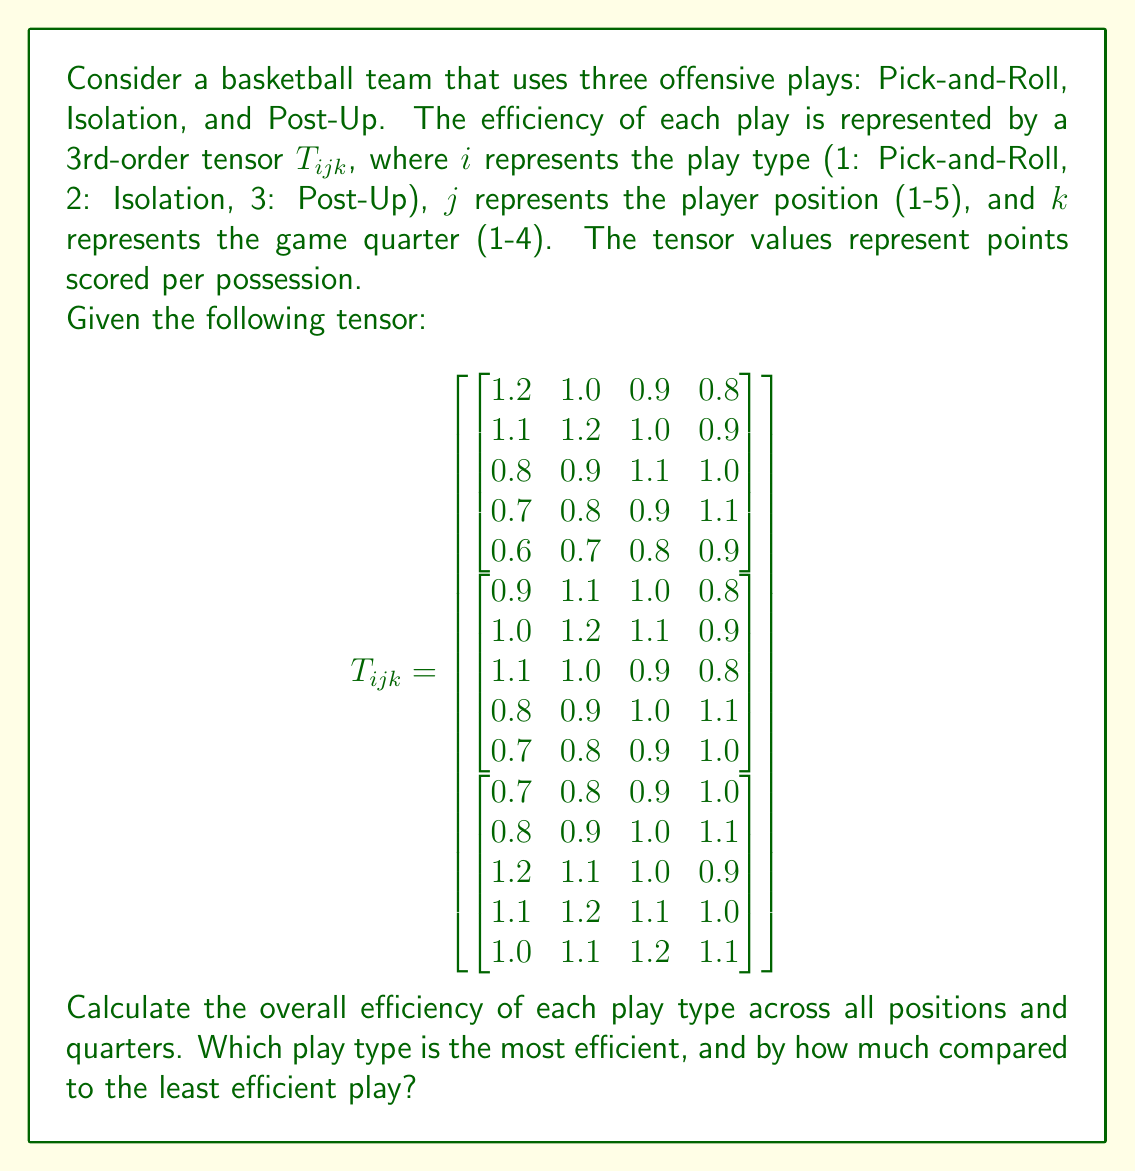Can you answer this question? To solve this problem, we'll follow these steps:

1) Calculate the average efficiency for each play type by summing all values for each play and dividing by the total number of elements (5 positions × 4 quarters = 20).

2) For Pick-and-Roll (i=1):
   Sum = 19.6
   Average = 19.6 / 20 = 0.98

3) For Isolation (i=2):
   Sum = 19.2
   Average = 19.2 / 20 = 0.96

4) For Post-Up (i=3):
   Sum = 20.1
   Average = 20.1 / 20 = 1.005

5) The most efficient play is Post-Up with an average of 1.005 points per possession.
   The least efficient play is Isolation with an average of 0.96 points per possession.

6) To calculate the difference:
   1.005 - 0.96 = 0.045 points per possession

Therefore, the Post-Up play is more efficient than the Isolation play by 0.045 points per possession.
Answer: Post-Up; 0.045 points per possession 